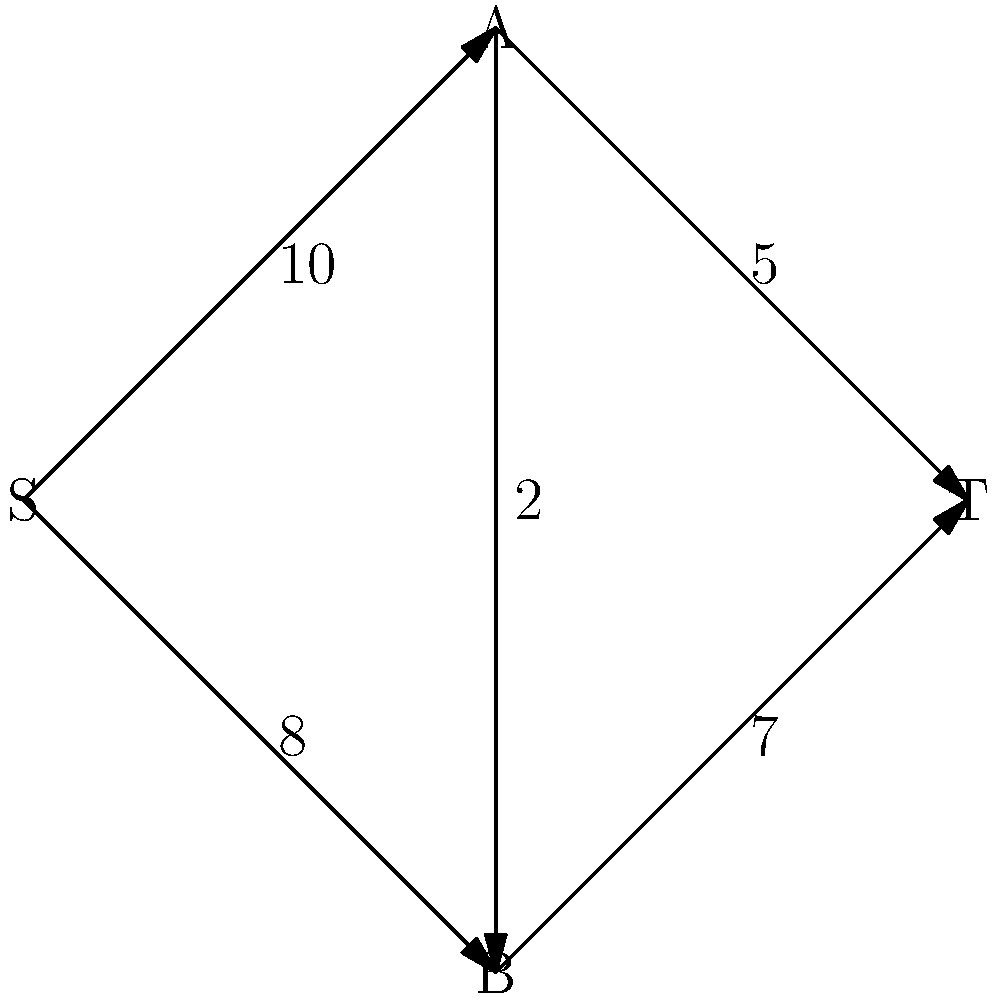At a body modification convention, customers flow through different stations. The diagram represents the maximum flow of customers per hour between stations, with S as the entrance, T as the exit, and A and B as intermediate stations. What is the maximum number of customers that can flow through the convention per hour? To solve this maximum flow problem, we'll use the Ford-Fulkerson algorithm:

1. Start with zero flow on all edges.

2. Find an augmenting path from S to T:
   S → A → T (min capacity: 5)
   Increase flow by 5.

3. Update residual graph and find another path:
   S → B → T (min capacity: 7)
   Increase flow by 7.

4. Update and find another path:
   S → A → B → T (min capacity: 2)
   Increase flow by 2.

5. Update and find another path:
   S → A → B → T (min capacity: 1)
   Increase flow by 1.

6. No more augmenting paths exist.

7. Sum the flows on edges leaving S:
   S → A: 8
   S → B: 7
   Total: 8 + 7 = 15

Therefore, the maximum flow is 15 customers per hour.
Answer: 15 customers per hour 